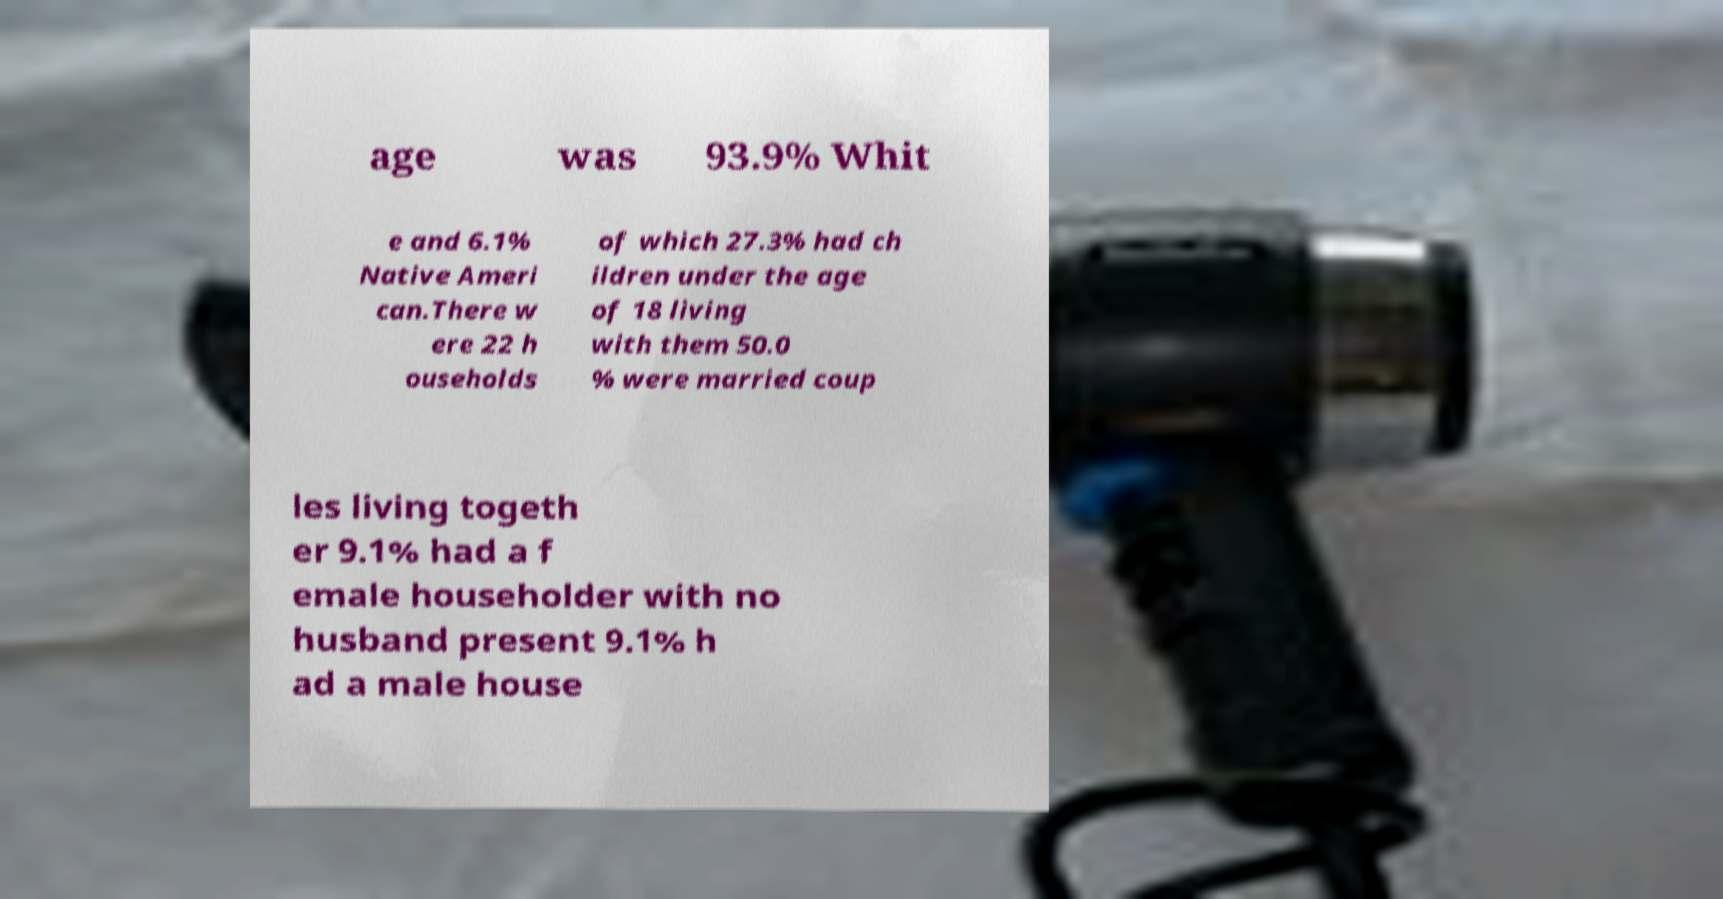Please identify and transcribe the text found in this image. age was 93.9% Whit e and 6.1% Native Ameri can.There w ere 22 h ouseholds of which 27.3% had ch ildren under the age of 18 living with them 50.0 % were married coup les living togeth er 9.1% had a f emale householder with no husband present 9.1% h ad a male house 